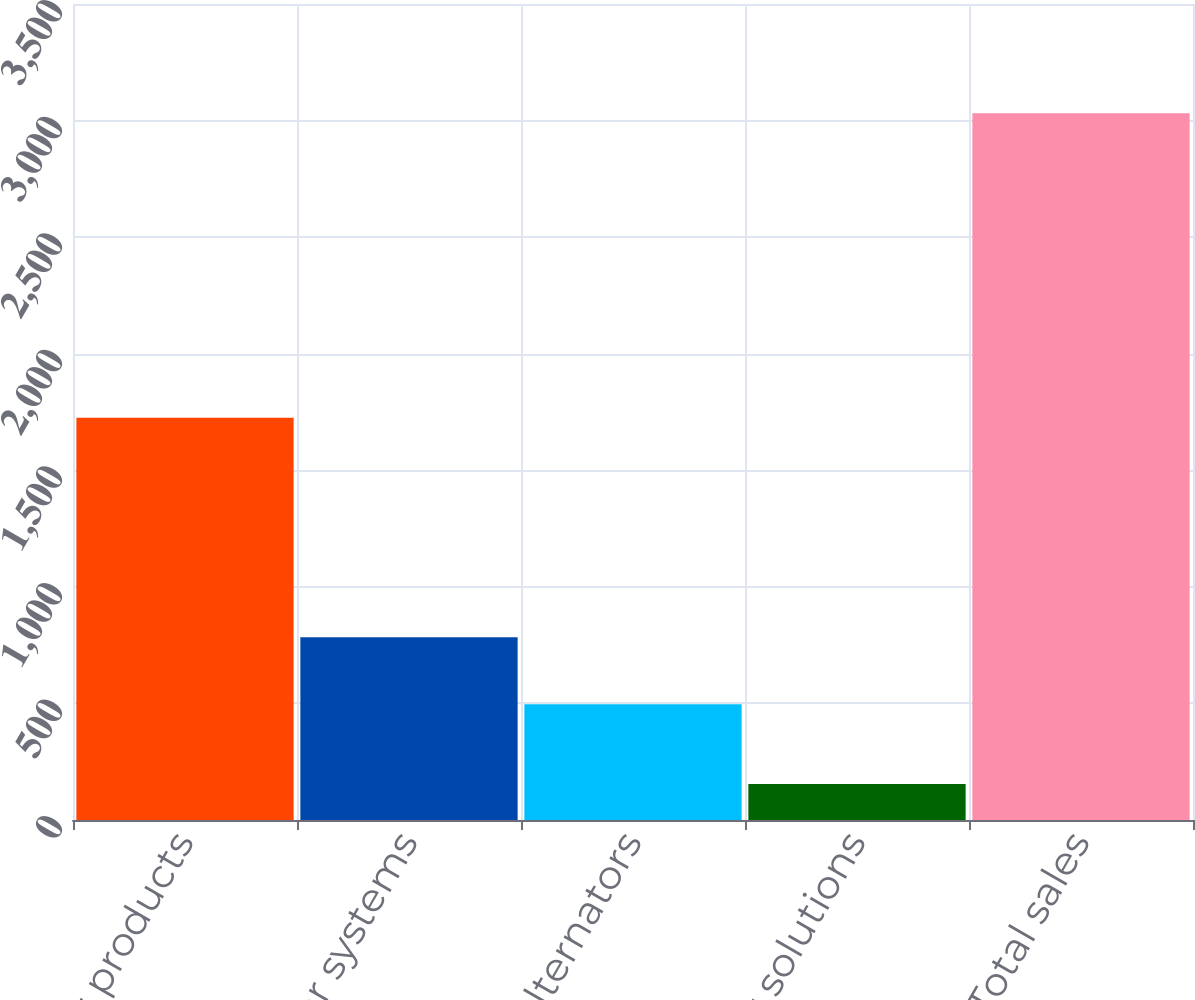Convert chart. <chart><loc_0><loc_0><loc_500><loc_500><bar_chart><fcel>Power products<fcel>Power systems<fcel>Alternators<fcel>Power solutions<fcel>Total sales<nl><fcel>1725<fcel>783.7<fcel>496<fcel>154<fcel>3031<nl></chart> 